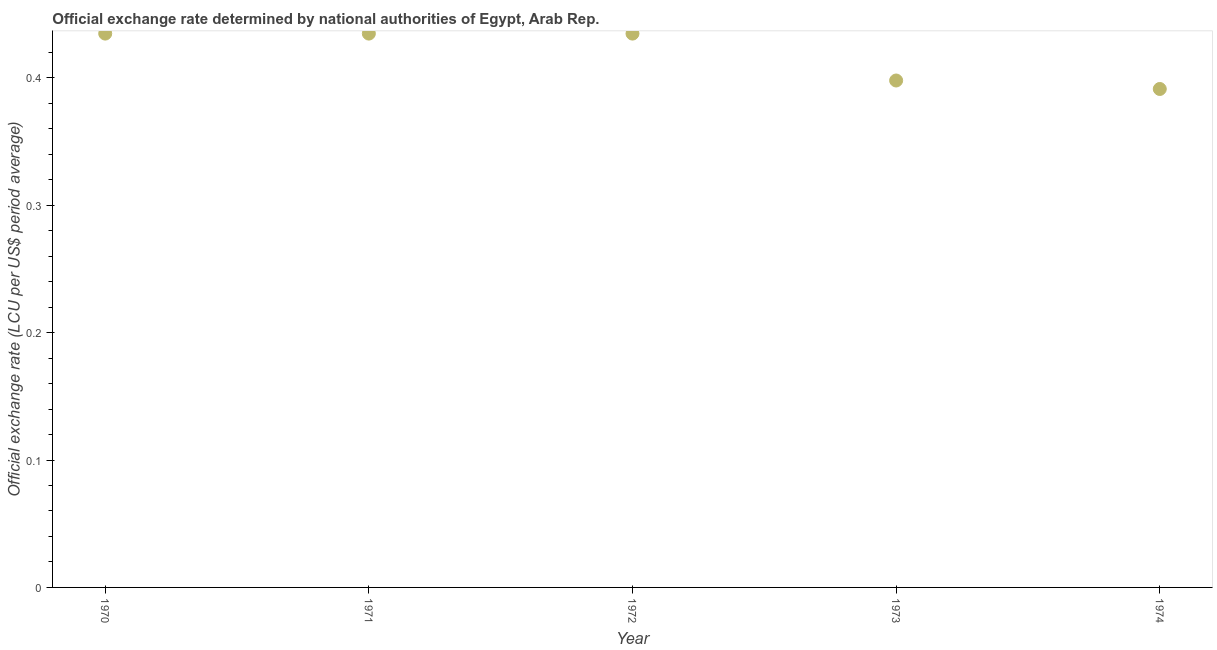What is the official exchange rate in 1974?
Ensure brevity in your answer.  0.39. Across all years, what is the maximum official exchange rate?
Keep it short and to the point. 0.43. Across all years, what is the minimum official exchange rate?
Offer a terse response. 0.39. In which year was the official exchange rate minimum?
Keep it short and to the point. 1974. What is the sum of the official exchange rate?
Your answer should be compact. 2.09. What is the difference between the official exchange rate in 1973 and 1974?
Ensure brevity in your answer.  0.01. What is the average official exchange rate per year?
Offer a terse response. 0.42. What is the median official exchange rate?
Provide a short and direct response. 0.43. In how many years, is the official exchange rate greater than 0.34 ?
Ensure brevity in your answer.  5. Do a majority of the years between 1973 and 1971 (inclusive) have official exchange rate greater than 0.30000000000000004 ?
Your response must be concise. No. What is the ratio of the official exchange rate in 1970 to that in 1973?
Your answer should be compact. 1.09. Is the official exchange rate in 1973 less than that in 1974?
Offer a very short reply. No. What is the difference between the highest and the second highest official exchange rate?
Keep it short and to the point. 3.901153119989509e-7. What is the difference between the highest and the lowest official exchange rate?
Provide a succinct answer. 0.04. Are the values on the major ticks of Y-axis written in scientific E-notation?
Make the answer very short. No. What is the title of the graph?
Your answer should be compact. Official exchange rate determined by national authorities of Egypt, Arab Rep. What is the label or title of the Y-axis?
Offer a very short reply. Official exchange rate (LCU per US$ period average). What is the Official exchange rate (LCU per US$ period average) in 1970?
Offer a very short reply. 0.43. What is the Official exchange rate (LCU per US$ period average) in 1971?
Provide a succinct answer. 0.43. What is the Official exchange rate (LCU per US$ period average) in 1972?
Your response must be concise. 0.43. What is the Official exchange rate (LCU per US$ period average) in 1973?
Provide a succinct answer. 0.4. What is the Official exchange rate (LCU per US$ period average) in 1974?
Offer a terse response. 0.39. What is the difference between the Official exchange rate (LCU per US$ period average) in 1970 and 1971?
Provide a short and direct response. -0. What is the difference between the Official exchange rate (LCU per US$ period average) in 1970 and 1972?
Provide a succinct answer. 0. What is the difference between the Official exchange rate (LCU per US$ period average) in 1970 and 1973?
Your answer should be compact. 0.04. What is the difference between the Official exchange rate (LCU per US$ period average) in 1970 and 1974?
Ensure brevity in your answer.  0.04. What is the difference between the Official exchange rate (LCU per US$ period average) in 1971 and 1972?
Your response must be concise. 0. What is the difference between the Official exchange rate (LCU per US$ period average) in 1971 and 1973?
Your answer should be compact. 0.04. What is the difference between the Official exchange rate (LCU per US$ period average) in 1971 and 1974?
Offer a very short reply. 0.04. What is the difference between the Official exchange rate (LCU per US$ period average) in 1972 and 1973?
Your answer should be compact. 0.04. What is the difference between the Official exchange rate (LCU per US$ period average) in 1972 and 1974?
Make the answer very short. 0.04. What is the difference between the Official exchange rate (LCU per US$ period average) in 1973 and 1974?
Keep it short and to the point. 0.01. What is the ratio of the Official exchange rate (LCU per US$ period average) in 1970 to that in 1972?
Your response must be concise. 1. What is the ratio of the Official exchange rate (LCU per US$ period average) in 1970 to that in 1973?
Ensure brevity in your answer.  1.09. What is the ratio of the Official exchange rate (LCU per US$ period average) in 1970 to that in 1974?
Your answer should be very brief. 1.11. What is the ratio of the Official exchange rate (LCU per US$ period average) in 1971 to that in 1972?
Keep it short and to the point. 1. What is the ratio of the Official exchange rate (LCU per US$ period average) in 1971 to that in 1973?
Keep it short and to the point. 1.09. What is the ratio of the Official exchange rate (LCU per US$ period average) in 1971 to that in 1974?
Your response must be concise. 1.11. What is the ratio of the Official exchange rate (LCU per US$ period average) in 1972 to that in 1973?
Offer a very short reply. 1.09. What is the ratio of the Official exchange rate (LCU per US$ period average) in 1972 to that in 1974?
Ensure brevity in your answer.  1.11. 